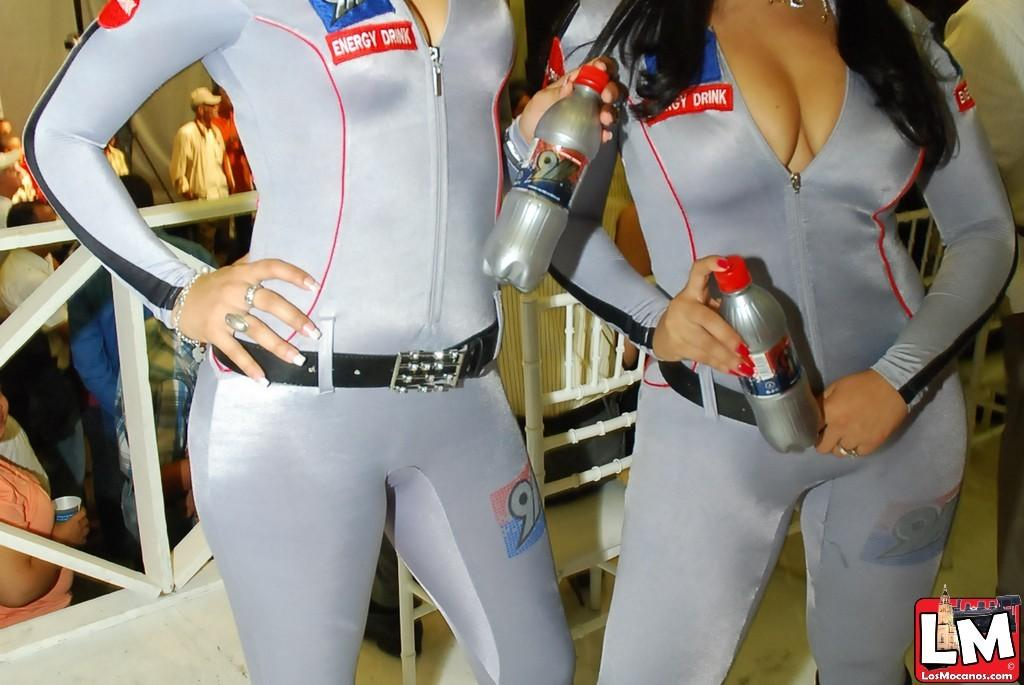How many women are in the image? There are two women in the image. What are the women wearing? The women are wearing grey dresses. What are the women holding in the image? The women are holding soft drink bottles. What can be seen in the background of the image? There are many people standing in the background of the image. What is the purpose of the fence visible in the image? The purpose of the fence is not clear from the image, but it could be used for separating areas or providing a boundary. What type of creature is sitting on the cart in the image? There is no cart or creature present in the image. 